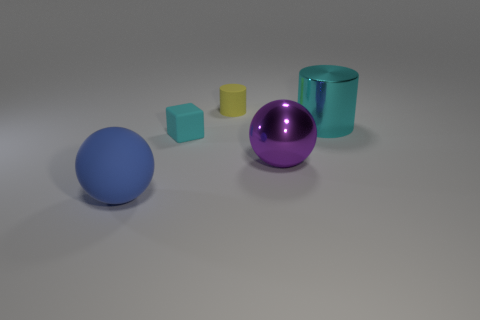Subtract all green cylinders. Subtract all gray balls. How many cylinders are left? 2 Add 4 big blue metal things. How many objects exist? 9 Subtract all balls. How many objects are left? 3 Add 4 tiny blue matte balls. How many tiny blue matte balls exist? 4 Subtract 0 purple blocks. How many objects are left? 5 Subtract all yellow rubber objects. Subtract all yellow matte cylinders. How many objects are left? 3 Add 1 rubber cylinders. How many rubber cylinders are left? 2 